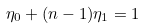Convert formula to latex. <formula><loc_0><loc_0><loc_500><loc_500>\eta _ { 0 } + ( n - 1 ) \eta _ { 1 } = 1</formula> 